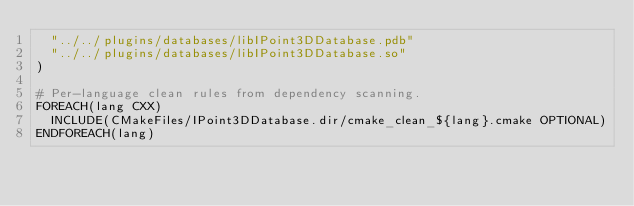<code> <loc_0><loc_0><loc_500><loc_500><_CMake_>  "../../plugins/databases/libIPoint3DDatabase.pdb"
  "../../plugins/databases/libIPoint3DDatabase.so"
)

# Per-language clean rules from dependency scanning.
FOREACH(lang CXX)
  INCLUDE(CMakeFiles/IPoint3DDatabase.dir/cmake_clean_${lang}.cmake OPTIONAL)
ENDFOREACH(lang)
</code> 